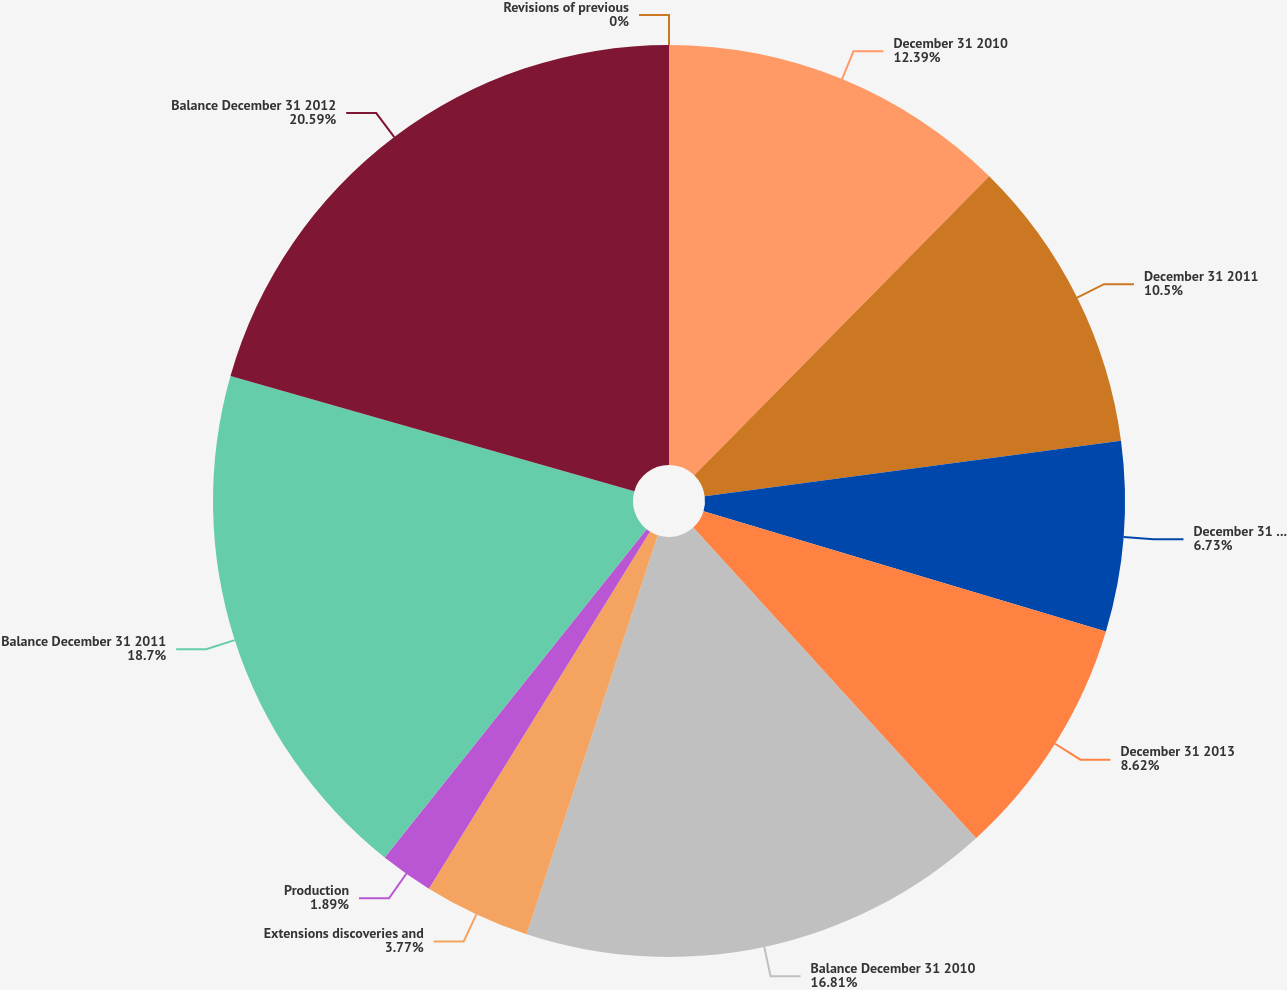Convert chart to OTSL. <chart><loc_0><loc_0><loc_500><loc_500><pie_chart><fcel>December 31 2010<fcel>December 31 2011<fcel>December 31 2012<fcel>December 31 2013<fcel>Balance December 31 2010<fcel>Extensions discoveries and<fcel>Production<fcel>Balance December 31 2011<fcel>Balance December 31 2012<fcel>Revisions of previous<nl><fcel>12.39%<fcel>10.5%<fcel>6.73%<fcel>8.62%<fcel>16.81%<fcel>3.77%<fcel>1.89%<fcel>18.7%<fcel>20.58%<fcel>0.0%<nl></chart> 